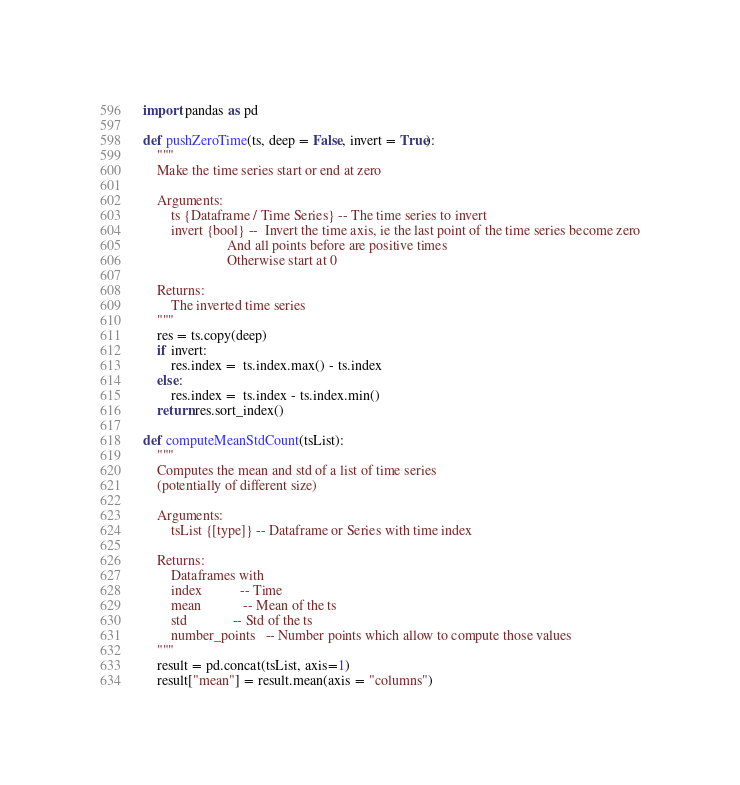<code> <loc_0><loc_0><loc_500><loc_500><_Python_>import pandas as pd

def pushZeroTime(ts, deep = False, invert = True):
    """
    Make the time series start or end at zero

    Arguments:
        ts {Dataframe / Time Series} -- The time series to invert
        invert {bool} --  Invert the time axis, ie the last point of the time series become zero
                        And all points before are positive times
                        Otherwise start at 0

    Returns:
        The inverted time series
    """
    res = ts.copy(deep)
    if invert:
        res.index =  ts.index.max() - ts.index
    else:
        res.index =  ts.index - ts.index.min() 
    return res.sort_index()

def computeMeanStdCount(tsList):
    """
    Computes the mean and std of a list of time series 
    (potentially of different size)
    
    Arguments:
        tsList {[type]} -- Dataframe or Series with time index

    Returns:
        Dataframes with 
        index           -- Time 
        mean            -- Mean of the ts
        std             -- Std of the ts
        number_points   -- Number points which allow to compute those values
    """
    result = pd.concat(tsList, axis=1)
    result["mean"] = result.mean(axis = "columns")</code> 